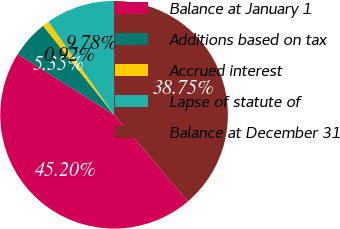<chart> <loc_0><loc_0><loc_500><loc_500><pie_chart><fcel>Balance at January 1<fcel>Additions based on tax<fcel>Accrued interest<fcel>Lapse of statute of<fcel>Balance at December 31<nl><fcel>45.2%<fcel>5.35%<fcel>0.92%<fcel>9.78%<fcel>38.75%<nl></chart> 